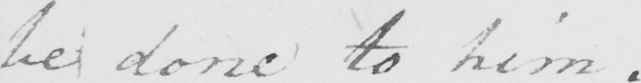Can you tell me what this handwritten text says? be done to him . 